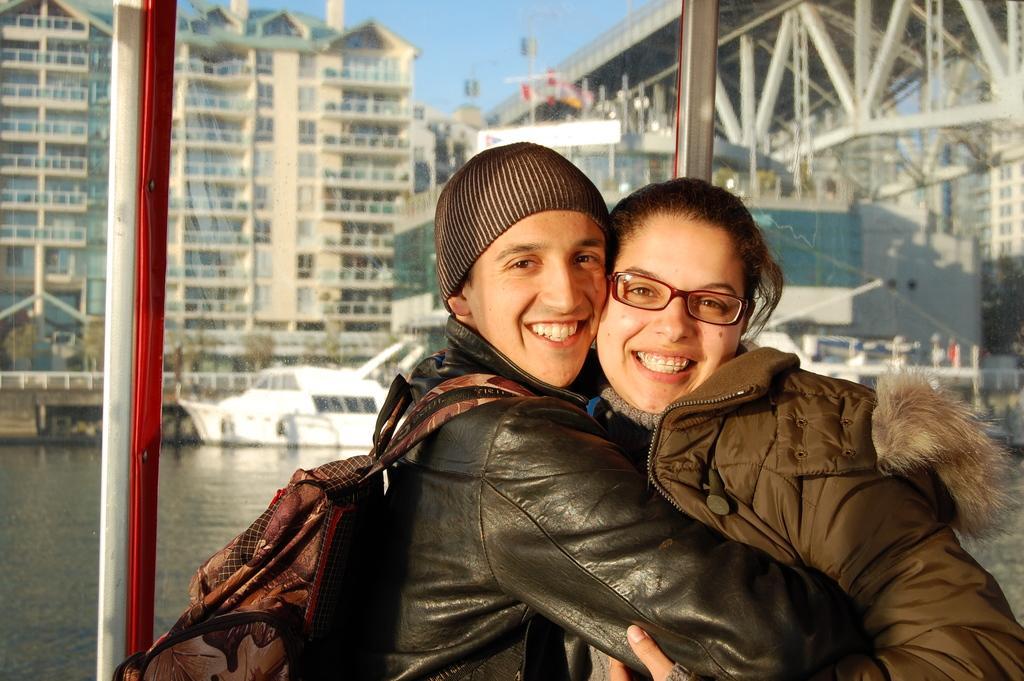Please provide a concise description of this image. In this image in the foreground there is one man and a woman who are smiling, and in the background there is a glass window and some buildings, poles. And at the bottom there is a river, in that river there are some boats. On the top of the image there is sky. 